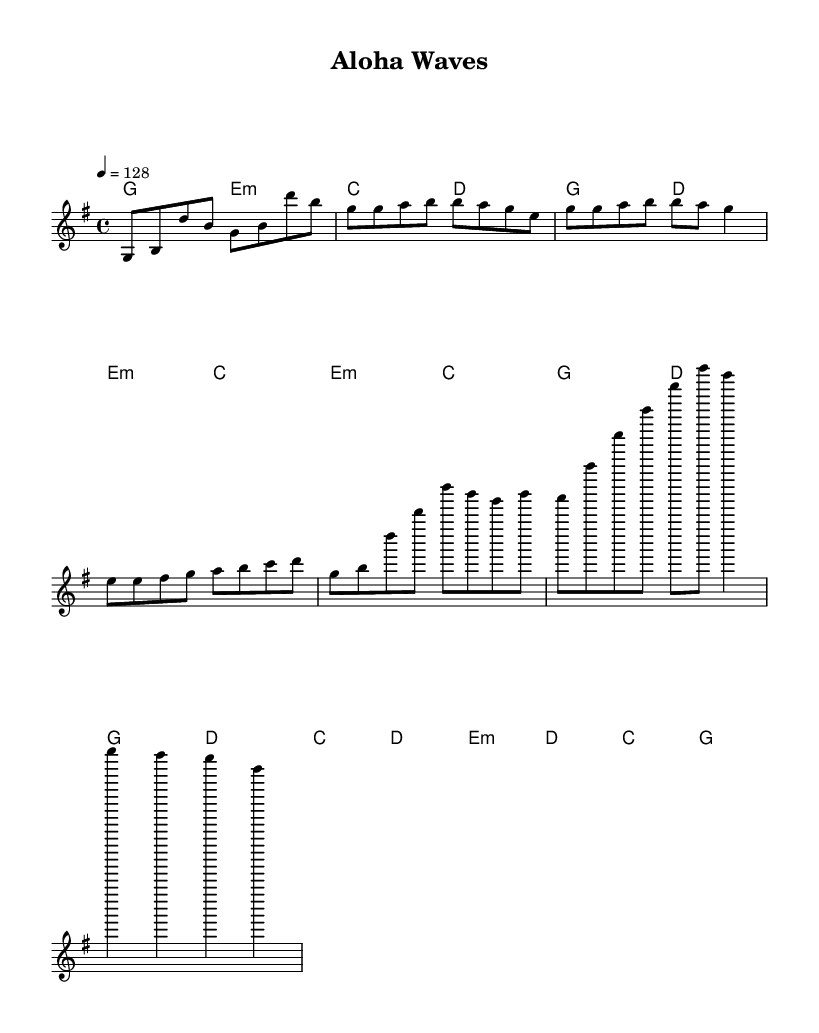What is the key signature of this music? The key signature is G major, indicated by one sharp (F#) in the music notation.
Answer: G major What is the time signature of this music? The time signature shown in the music is 4/4, which means there are four beats per measure and the quarter note gets one beat.
Answer: 4/4 What is the tempo marking of the piece? The tempo marking is indicated as 128 beats per minute, which suggests a lively and upbeat feel typical of K-Pop tracks.
Answer: 128 What is the name of the piece? The title “Aloha Waves” is provided in the header section of the sheet music, reflecting its tropical theme.
Answer: Aloha Waves How many sections are in the piece? The piece consists of five sections: Intro, Verse, Pre-Chorus, Chorus, and Bridge, suggesting a typical song structure.
Answer: Five What is the harmony for the Chorus section? The harmony for the Chorus section is composed of G and D chords, as indicated in the harmony section where "g2 d" appears, marking the chord progression.
Answer: G, D Which instrument is typically associated with the ukulele influence? The ukulele, prevalent in Hawaiian music and characterized by its four nylon or gut strings, is suggested by the sections handling melodic and harmonic interplay that align with its sound.
Answer: Ukulele 